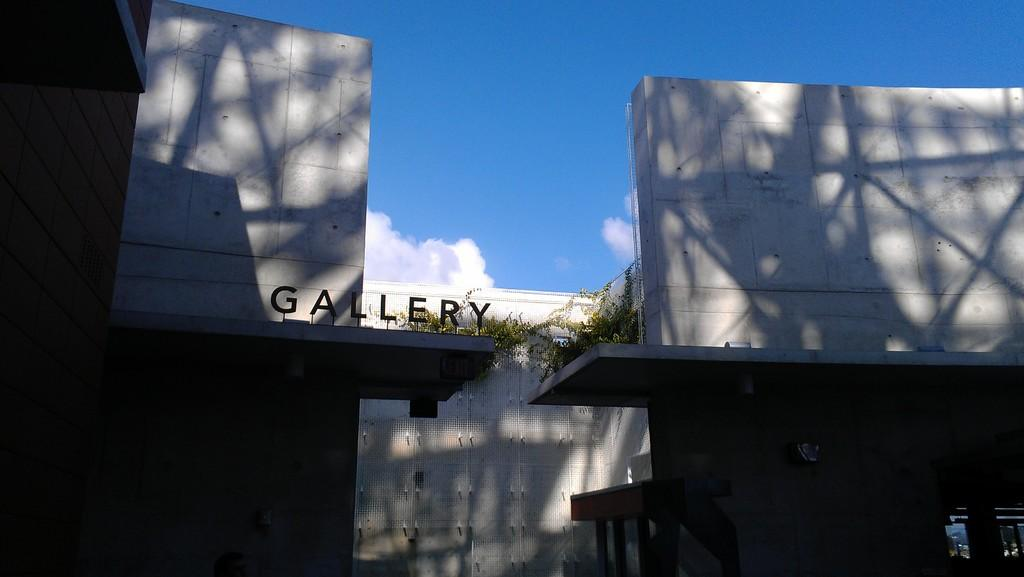What is the main subject in the foreground of the image? There is a building in the foreground of the image. What can be seen on the building? The building has some text on it. What type of vegetation is present on the building? There is greenery on the building. What is visible at the top of the image? The sky is visible at the top of the image. Where is the table located in the image? There is no table present in the image. What type of heart can be seen beating in the image? There is no heart visible in the image. 